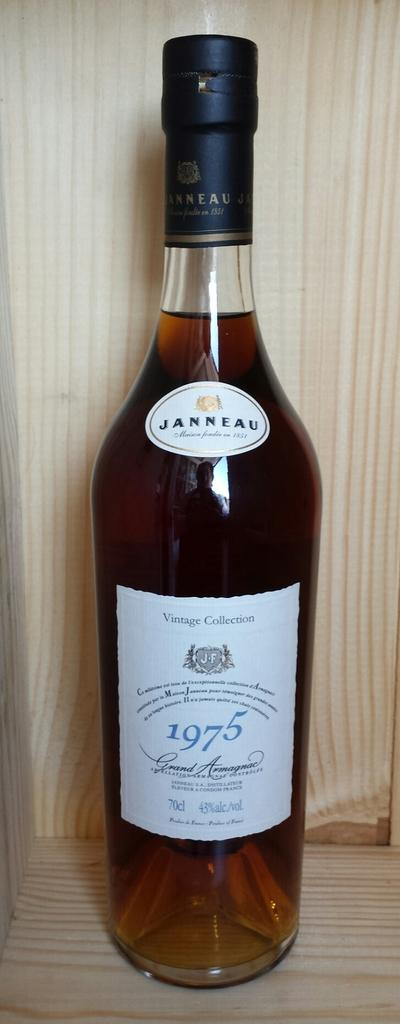<image>
Relay a brief, clear account of the picture shown. A bottle of 1975 Janneau is on a wooden shelf for a display. 